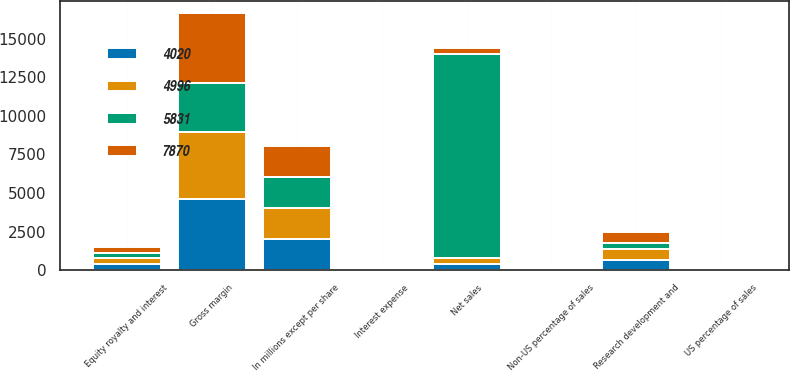<chart> <loc_0><loc_0><loc_500><loc_500><stacked_bar_chart><ecel><fcel>In millions except per share<fcel>Net sales<fcel>US percentage of sales<fcel>Non-US percentage of sales<fcel>Gross margin<fcel>Research development and<fcel>Equity royalty and interest<fcel>Interest expense<nl><fcel>4996<fcel>2013<fcel>384<fcel>48<fcel>52<fcel>4383<fcel>713<fcel>361<fcel>41<nl><fcel>7870<fcel>2012<fcel>384<fcel>47<fcel>53<fcel>4508<fcel>728<fcel>384<fcel>32<nl><fcel>4020<fcel>2011<fcel>384<fcel>41<fcel>59<fcel>4589<fcel>629<fcel>416<fcel>44<nl><fcel>5831<fcel>2010<fcel>13226<fcel>36<fcel>64<fcel>3168<fcel>414<fcel>351<fcel>40<nl></chart> 